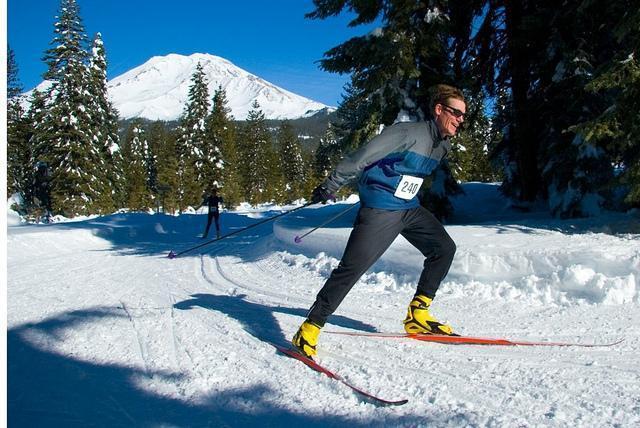How many skiers are on the descent?
Give a very brief answer. 2. 